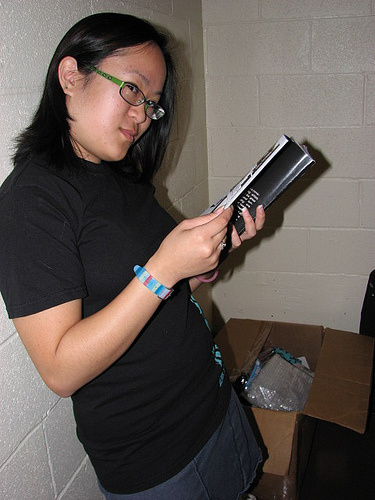<image>
Can you confirm if the magazine is in the box? No. The magazine is not contained within the box. These objects have a different spatial relationship. 